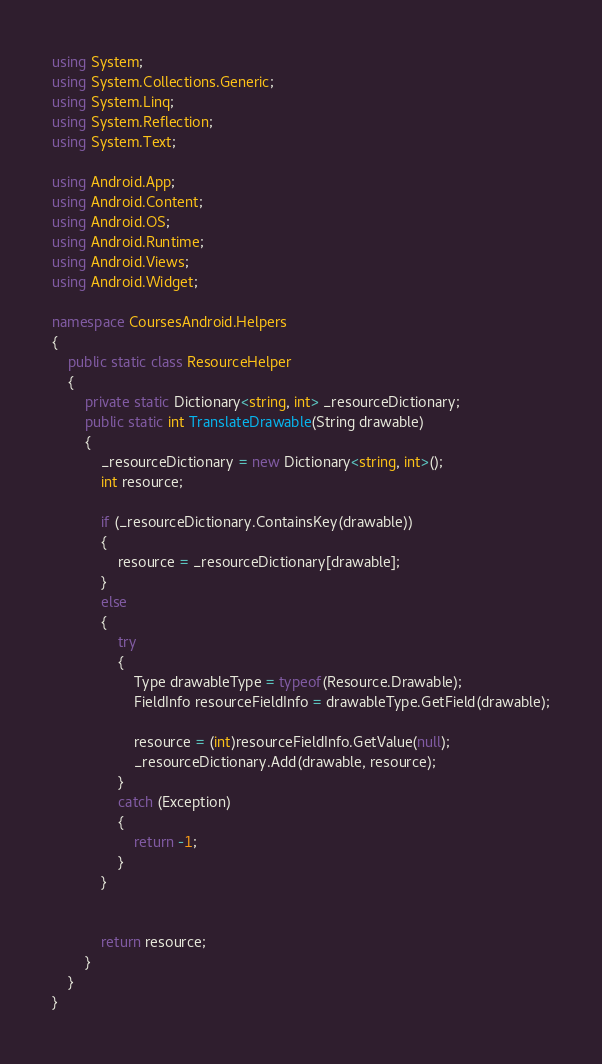<code> <loc_0><loc_0><loc_500><loc_500><_C#_>using System;
using System.Collections.Generic;
using System.Linq;
using System.Reflection;
using System.Text;

using Android.App;
using Android.Content;
using Android.OS;
using Android.Runtime;
using Android.Views;
using Android.Widget;

namespace CoursesAndroid.Helpers
{
    public static class ResourceHelper
    {
        private static Dictionary<string, int> _resourceDictionary; 
        public static int TranslateDrawable(String drawable)
        {
            _resourceDictionary = new Dictionary<string, int>();
            int resource;

            if (_resourceDictionary.ContainsKey(drawable))
            {
                resource = _resourceDictionary[drawable];
            }
            else
            {
                try
                {
                    Type drawableType = typeof(Resource.Drawable);
                    FieldInfo resourceFieldInfo = drawableType.GetField(drawable);

                    resource = (int)resourceFieldInfo.GetValue(null);
                    _resourceDictionary.Add(drawable, resource);
                }
                catch (Exception)
                {
                    return -1;
                }
            }

            
            return resource;
        }
    }
}</code> 